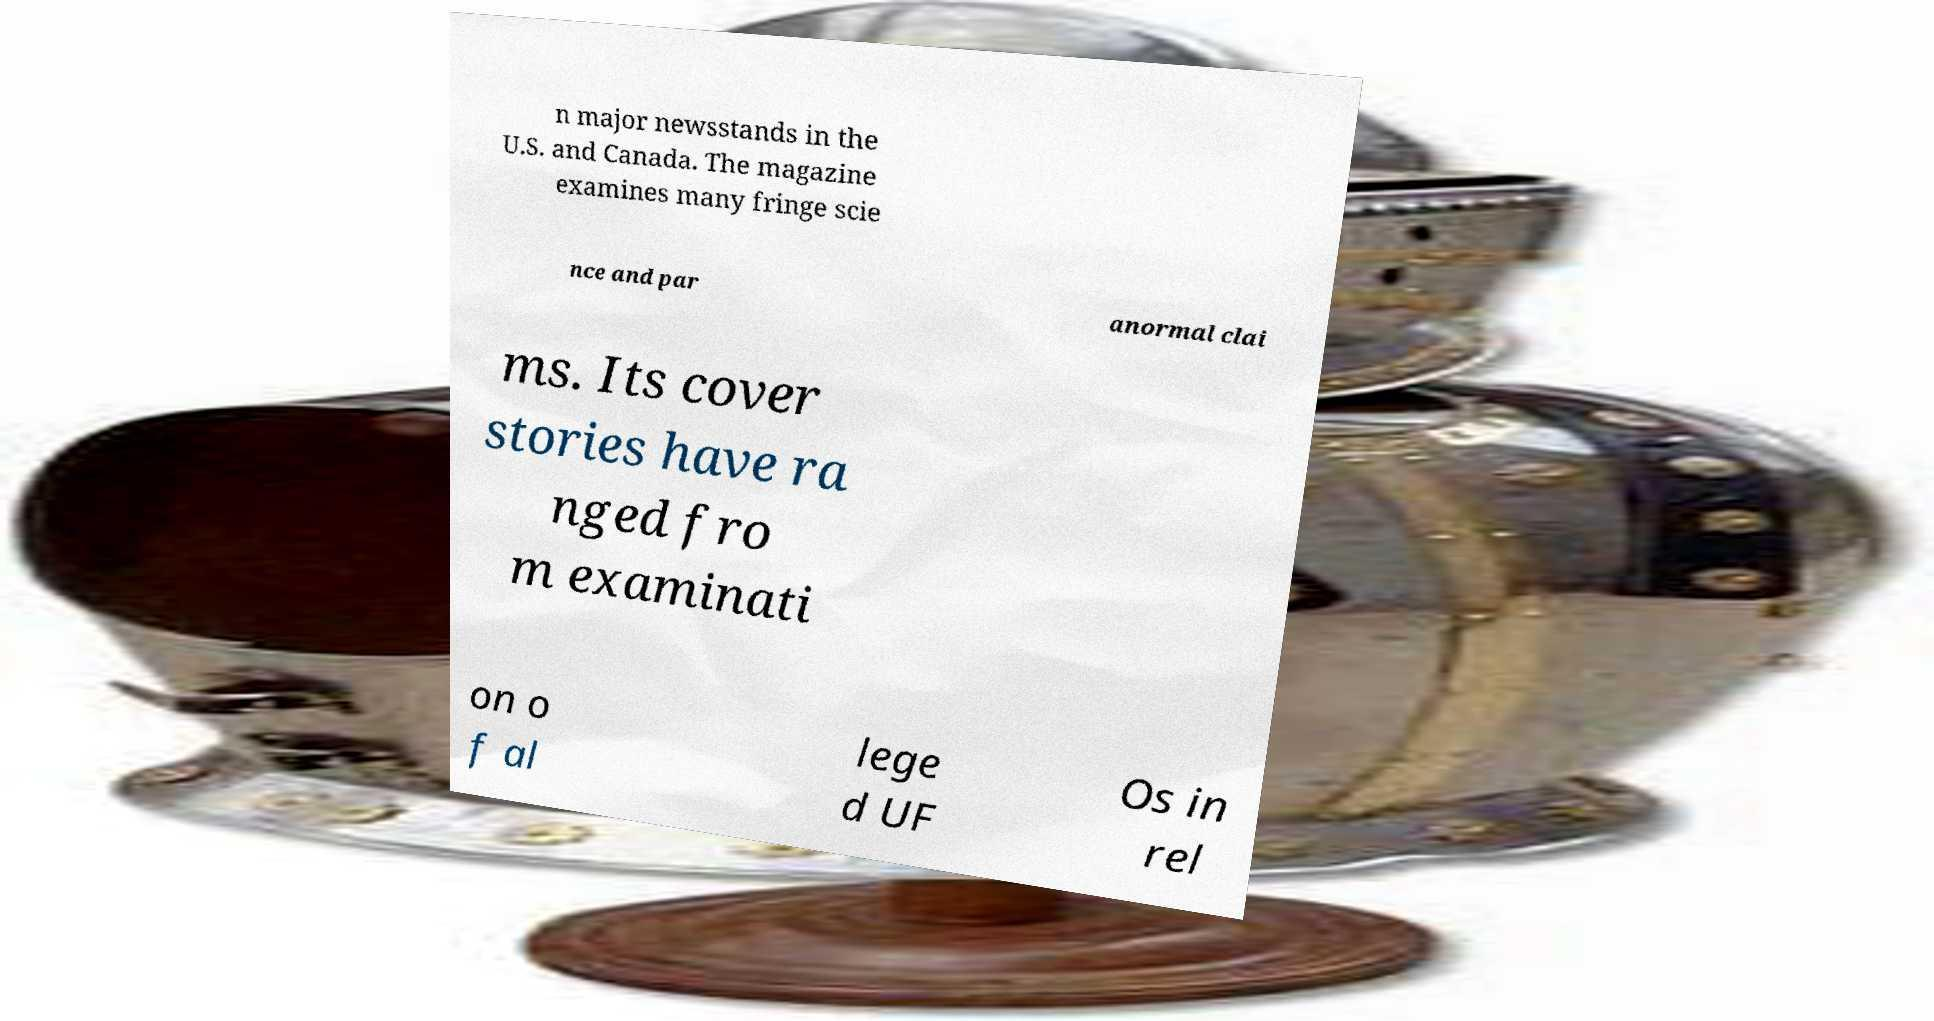Can you accurately transcribe the text from the provided image for me? n major newsstands in the U.S. and Canada. The magazine examines many fringe scie nce and par anormal clai ms. Its cover stories have ra nged fro m examinati on o f al lege d UF Os in rel 